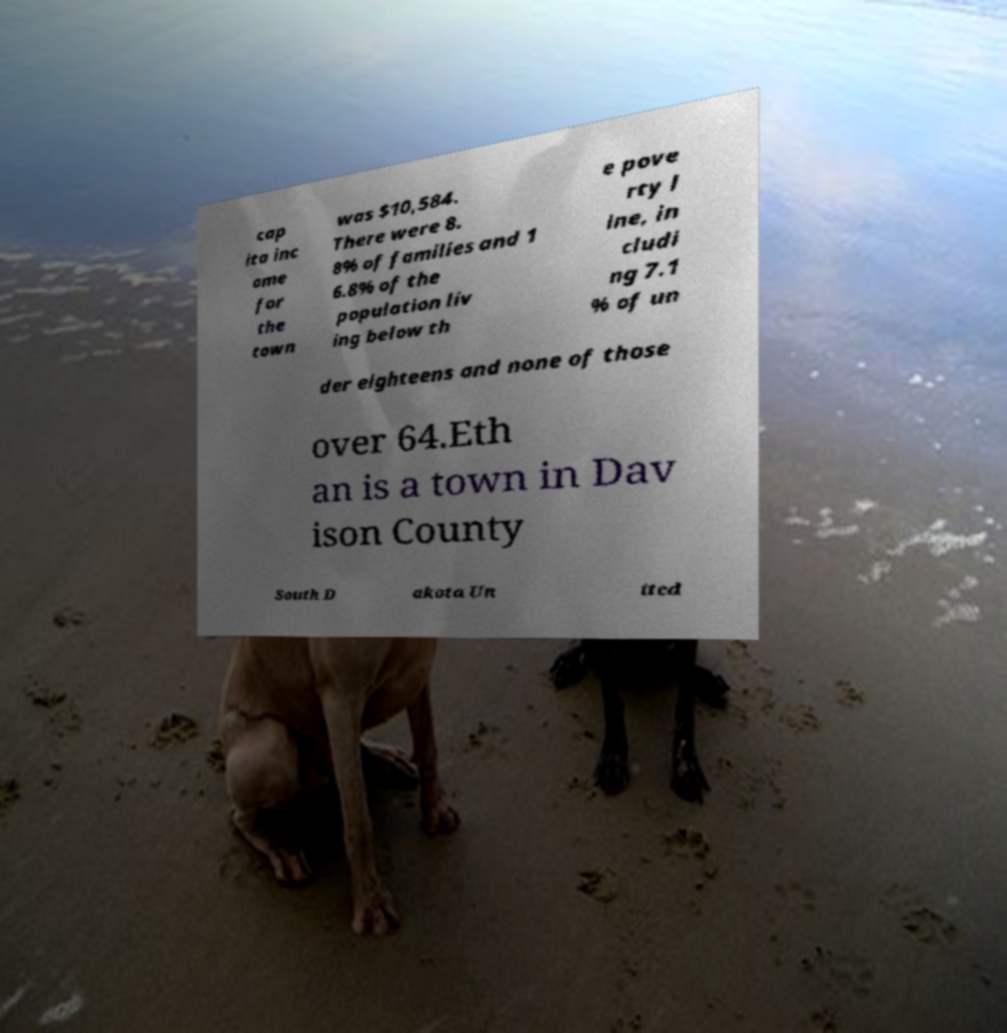Can you read and provide the text displayed in the image?This photo seems to have some interesting text. Can you extract and type it out for me? cap ita inc ome for the town was $10,584. There were 8. 8% of families and 1 6.8% of the population liv ing below th e pove rty l ine, in cludi ng 7.1 % of un der eighteens and none of those over 64.Eth an is a town in Dav ison County South D akota Un ited 